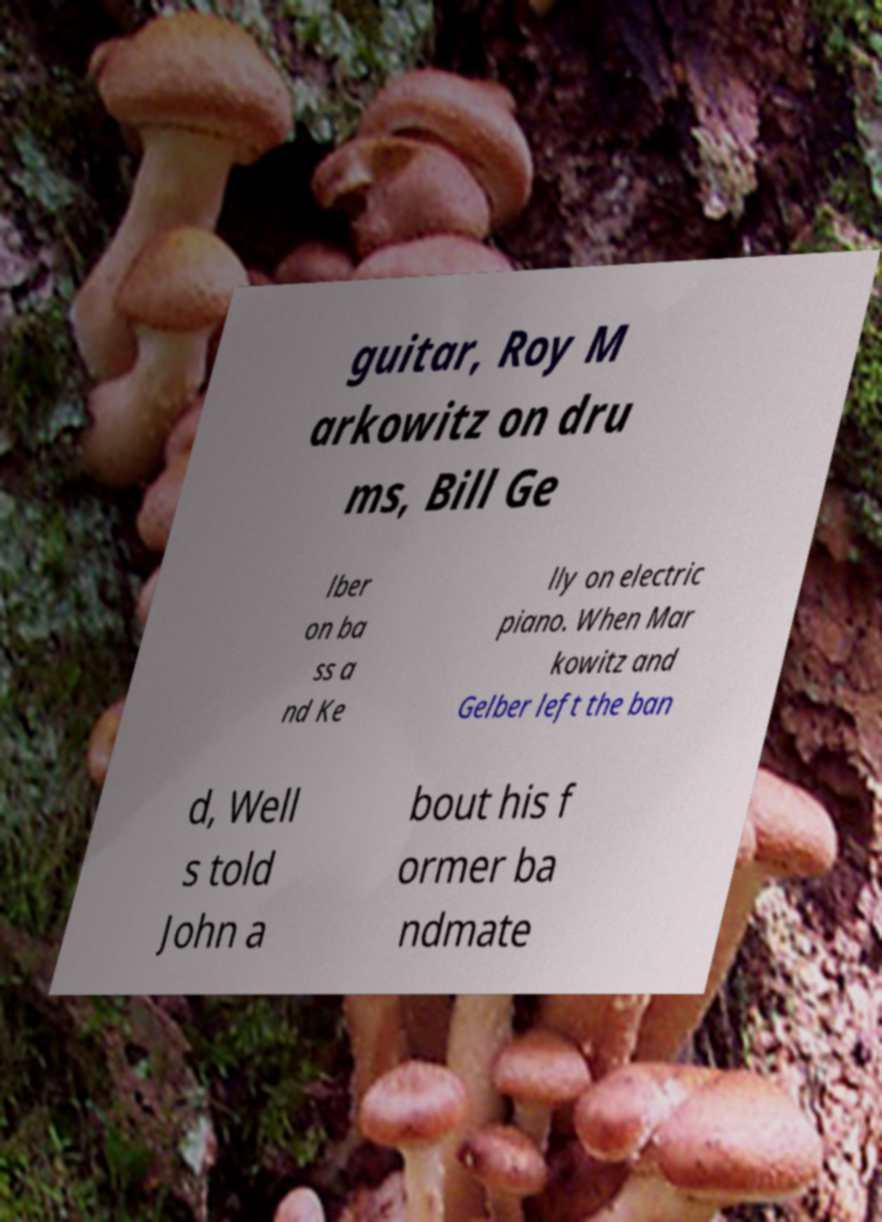Could you extract and type out the text from this image? guitar, Roy M arkowitz on dru ms, Bill Ge lber on ba ss a nd Ke lly on electric piano. When Mar kowitz and Gelber left the ban d, Well s told John a bout his f ormer ba ndmate 